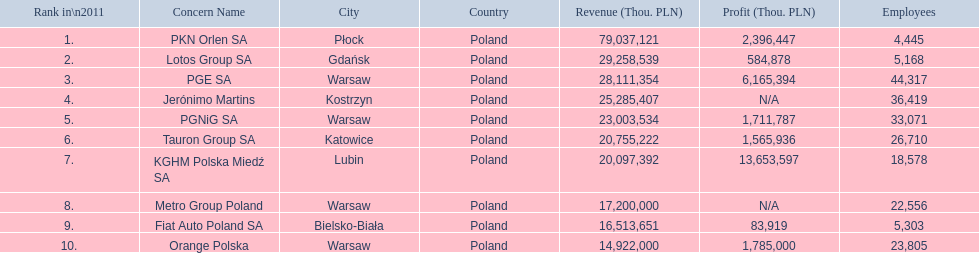What companies are listed? PKN Orlen SA, Lotos Group SA, PGE SA, Jerónimo Martins, PGNiG SA, Tauron Group SA, KGHM Polska Miedź SA, Metro Group Poland, Fiat Auto Poland SA, Orange Polska. What are the company's revenues? 79 037 121, 29 258 539, 28 111 354, 25 285 407, 23 003 534, 20 755 222, 20 097 392, 17 200 000, 16 513 651, 14 922 000. Which company has the greatest revenue? PKN Orlen SA. 